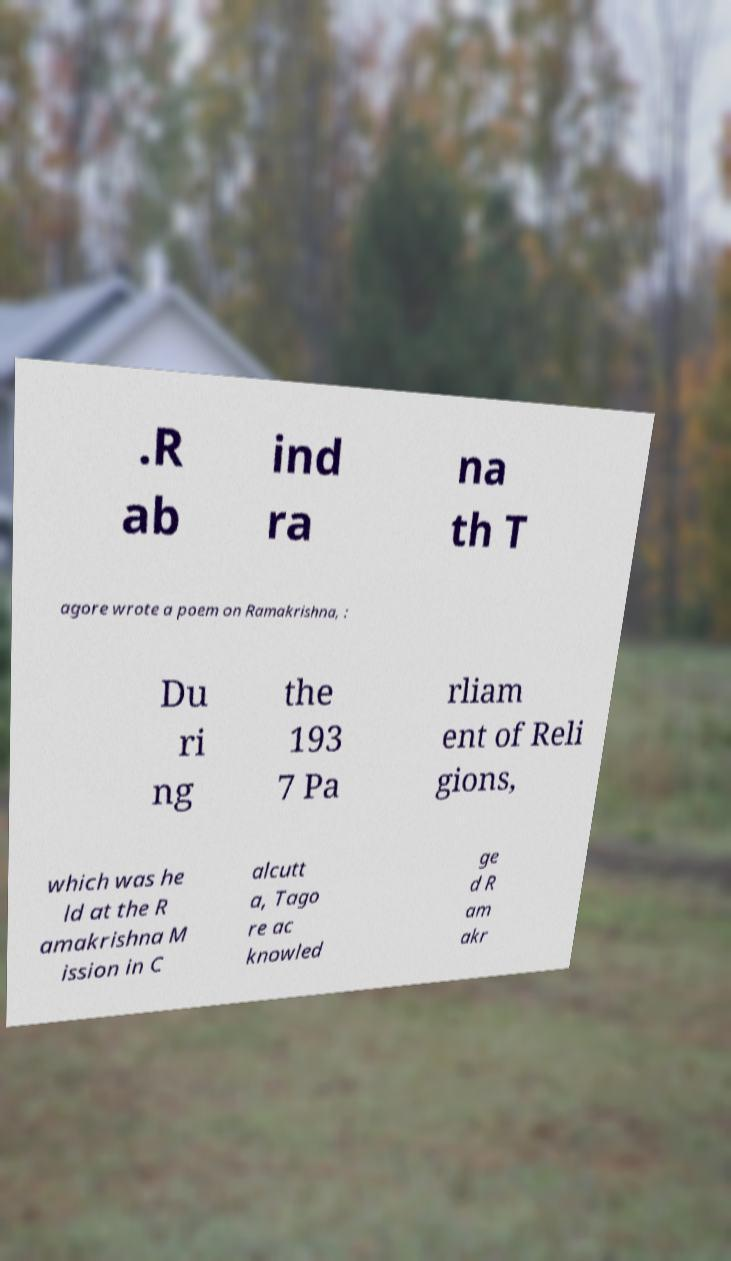There's text embedded in this image that I need extracted. Can you transcribe it verbatim? .R ab ind ra na th T agore wrote a poem on Ramakrishna, : Du ri ng the 193 7 Pa rliam ent of Reli gions, which was he ld at the R amakrishna M ission in C alcutt a, Tago re ac knowled ge d R am akr 